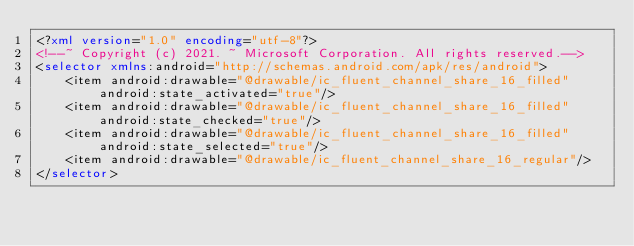Convert code to text. <code><loc_0><loc_0><loc_500><loc_500><_XML_><?xml version="1.0" encoding="utf-8"?>
<!--~ Copyright (c) 2021. ~ Microsoft Corporation. All rights reserved.-->
<selector xmlns:android="http://schemas.android.com/apk/res/android">
    <item android:drawable="@drawable/ic_fluent_channel_share_16_filled" android:state_activated="true"/>
    <item android:drawable="@drawable/ic_fluent_channel_share_16_filled" android:state_checked="true"/>
    <item android:drawable="@drawable/ic_fluent_channel_share_16_filled" android:state_selected="true"/>
    <item android:drawable="@drawable/ic_fluent_channel_share_16_regular"/>
</selector>
</code> 